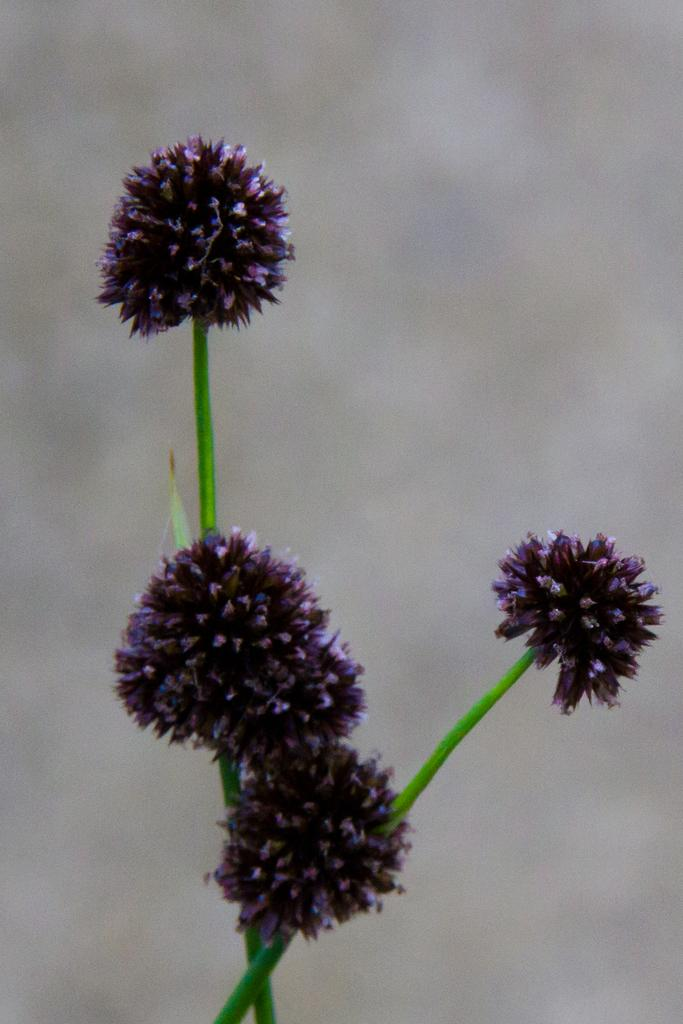What type of living organisms can be seen in the image? There are flowers in the image. What color are the flowers in the image? The flowers are in violet color. What type of furniture is present in the image? There is no furniture present in the image; it only features flowers. What type of pan can be seen in the image? There is no pan present in the image; it only features flowers. 